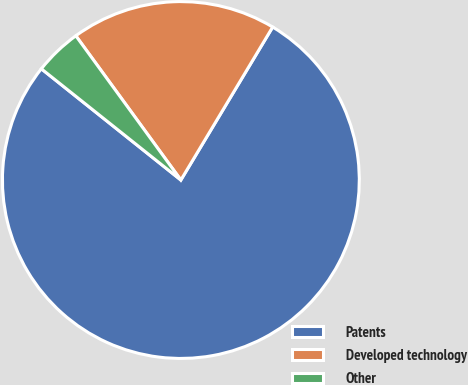Convert chart to OTSL. <chart><loc_0><loc_0><loc_500><loc_500><pie_chart><fcel>Patents<fcel>Developed technology<fcel>Other<nl><fcel>77.11%<fcel>18.62%<fcel>4.27%<nl></chart> 